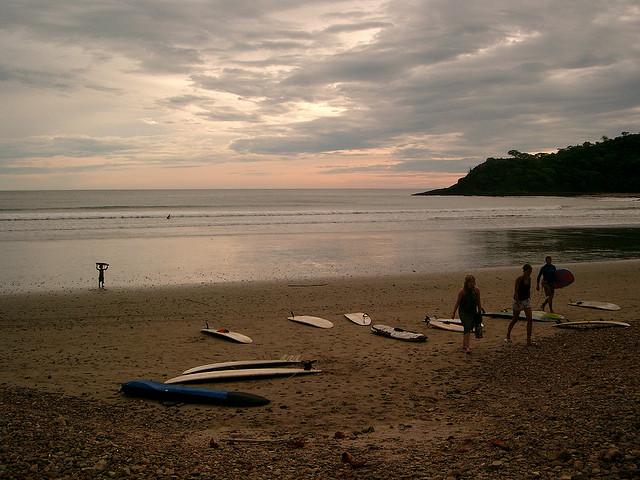Does this surfboard belong to someone?
Keep it brief. Yes. Are there people on the beach?
Quick response, please. Yes. Is there people in the water?
Short answer required. No. Is it cloudy?
Concise answer only. Yes. Is a sunrise or sunset?
Quick response, please. Sunset. Are the 3 people on the right getting ready to go in the water?
Be succinct. No. Is the water turbulent?
Answer briefly. No. 